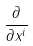Convert formula to latex. <formula><loc_0><loc_0><loc_500><loc_500>\frac { \partial } { \partial x ^ { i } }</formula> 